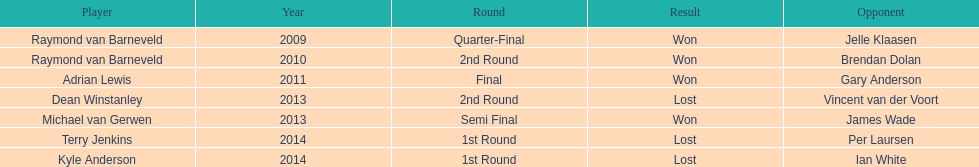Is dean winstanley positioned over or under kyle anderson? Above. 